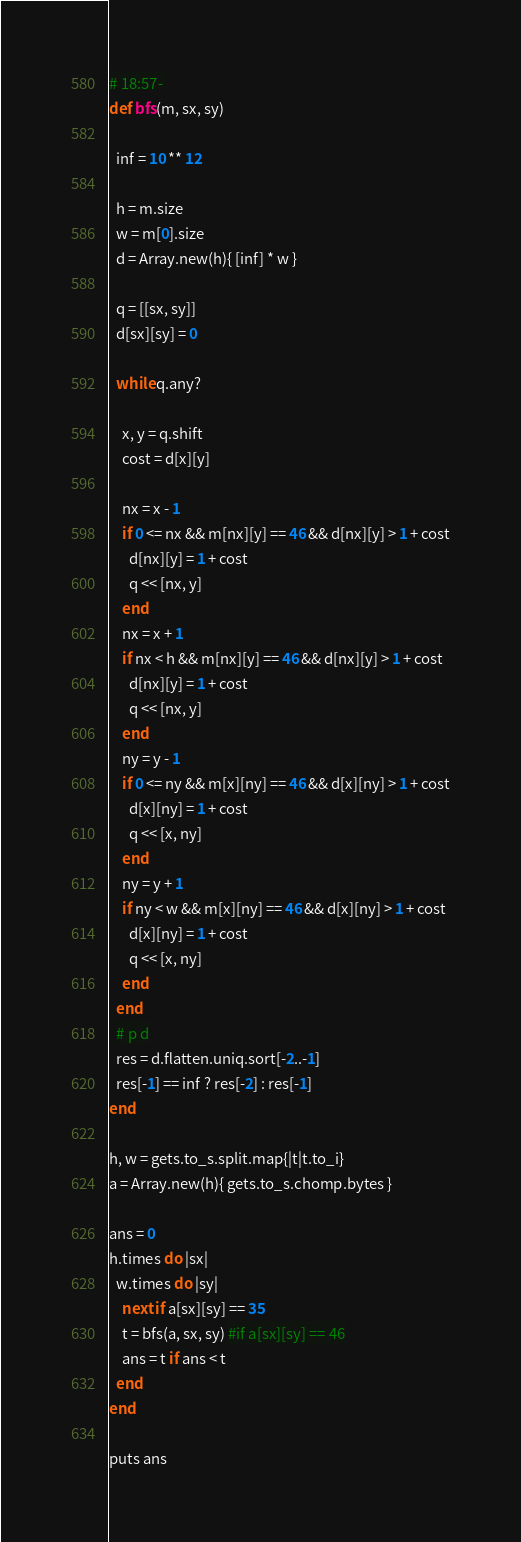<code> <loc_0><loc_0><loc_500><loc_500><_Ruby_># 18:57-
def bfs(m, sx, sy)
  
  inf = 10 ** 12
  
  h = m.size
  w = m[0].size
  d = Array.new(h){ [inf] * w }
  
  q = [[sx, sy]]
  d[sx][sy] = 0
  
  while q.any?
    
    x, y = q.shift
    cost = d[x][y]
    
    nx = x - 1
    if 0 <= nx && m[nx][y] == 46 && d[nx][y] > 1 + cost
      d[nx][y] = 1 + cost
      q << [nx, y]
    end
    nx = x + 1
    if nx < h && m[nx][y] == 46 && d[nx][y] > 1 + cost
      d[nx][y] = 1 + cost
      q << [nx, y]
    end
    ny = y - 1
    if 0 <= ny && m[x][ny] == 46 && d[x][ny] > 1 + cost
      d[x][ny] = 1 + cost
      q << [x, ny]
    end
    ny = y + 1
    if ny < w && m[x][ny] == 46 && d[x][ny] > 1 + cost
      d[x][ny] = 1 + cost
      q << [x, ny]
    end
  end
  # p d
  res = d.flatten.uniq.sort[-2..-1]
  res[-1] == inf ? res[-2] : res[-1]
end

h, w = gets.to_s.split.map{|t|t.to_i}
a = Array.new(h){ gets.to_s.chomp.bytes }

ans = 0
h.times do |sx|
  w.times do |sy|
    next if a[sx][sy] == 35
    t = bfs(a, sx, sy) #if a[sx][sy] == 46
    ans = t if ans < t
  end
end

puts ans</code> 